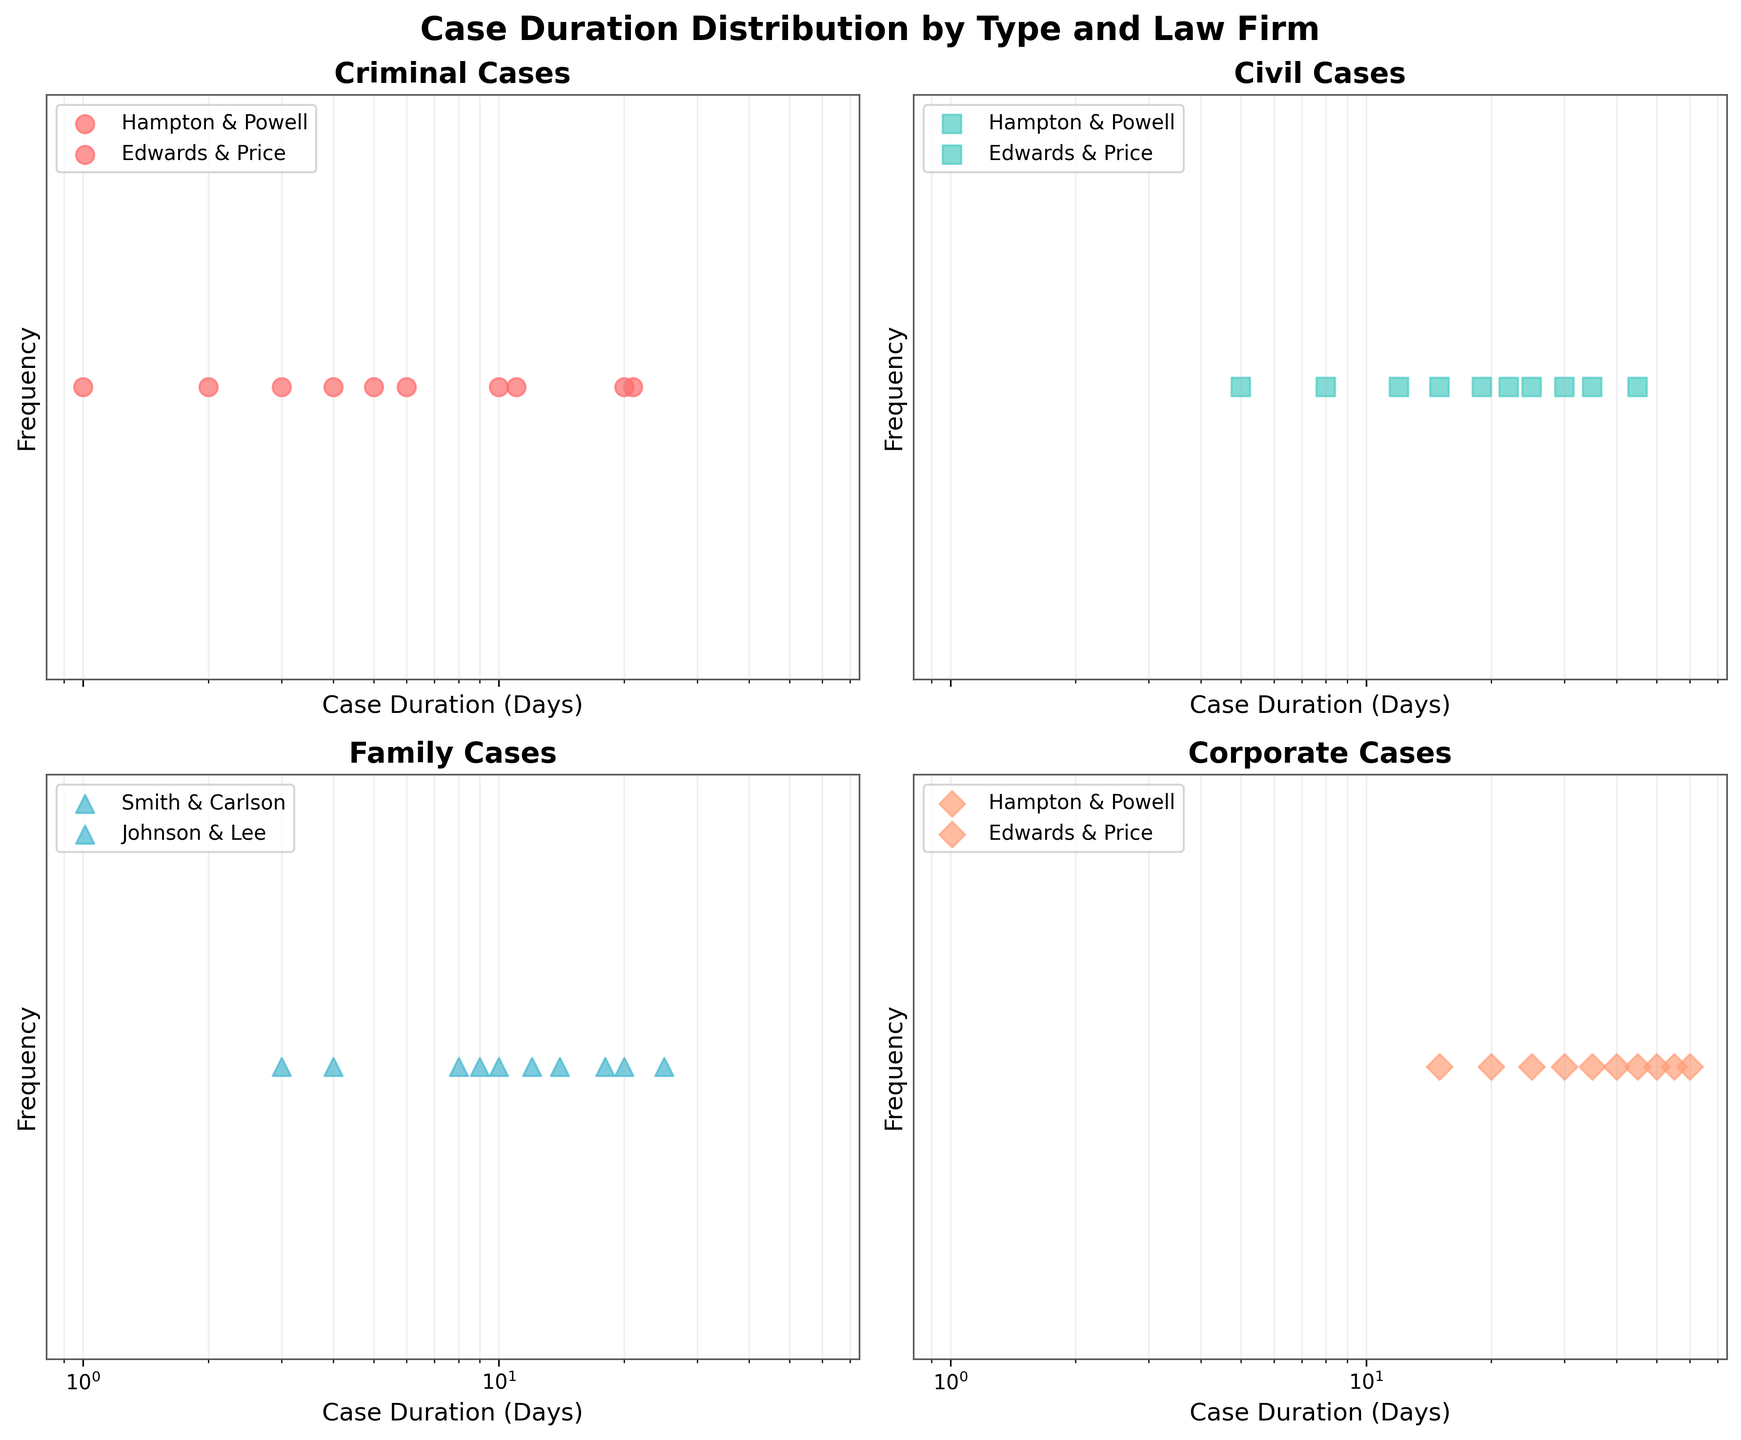What is the title of the entire figure? The title of the figure can be seen at the top of the plot. It reads: 'Case Duration Distribution by Type and Law Firm'.
Answer: Case Duration Distribution by Type and Law Firm Which case type has the most firms represented? By looking at the four subplots, we can see that only two firms are representing Criminal, Civil, and Corporate cases, while three firms are representing Family cases.
Answer: Family How is the x-axis scaled in the subplots? All four subplots have their x-axis scaled logarithmically, evident from the unevenly spaced tick marks indicating exponential scaling of days.
Answer: Logarithmic Which law firm has the highest duration for a Corporate case? By examining the Corporate cases subplot, we can see that Hampton & Powell has the highest case duration, reaching up to 60 days.
Answer: Hampton & Powell What's the range of case durations for Civil cases handled by Edwards & Price? In the subplot for Civil cases, Edwards & Price handles cases with durations ranging from 5 to 35 days.
Answer: 5 to 35 days Which subplot has the data points with the lowest case durations? By comparing the lowest case durations in each subplot, the Criminal cases subplot has a point at 1 day, whereas others have higher minimum points.
Answer: Criminal How do the durations of Family cases handled by Johnson & Lee compare to those handled by Smith & Carlson? In the subplot for Family cases, Johnson & Lee ranges from 4 to 25 days, while Smith & Carlson ranges from 3 to 18 days. Smith & Carlson's range is both shorter and lower.
Answer: Smith & Carlson's are shorter and lower What is the maximum case duration for Criminal cases? The maximum case duration can be found in the Criminal cases subplot, where Edwards & Price has a case lasting 21 days.
Answer: 21 days Which law firm has a case lasting exactly 10 days in a Criminal case? In the Criminal cases subplot, Hampton & Powell has a data point at exactly 10 days.
Answer: Hampton & Powell Compare the average case durations for Criminal cases handled by Hampton & Powell and Edwards & Price. Hampton & Powell has case durations of 2, 3, 5, 10, and 20 days. Edwards & Price has 1, 4, 6, 11, and 21 days. The average for Hampton & Powell is (2+3+5+10+20)/5 = 8 days; for Edwards & Price is (1+4+6+11+21)/5 = 8.6 days.
Answer: Hampton & Powell: 8 days, Edwards & Price: 8.6 days 